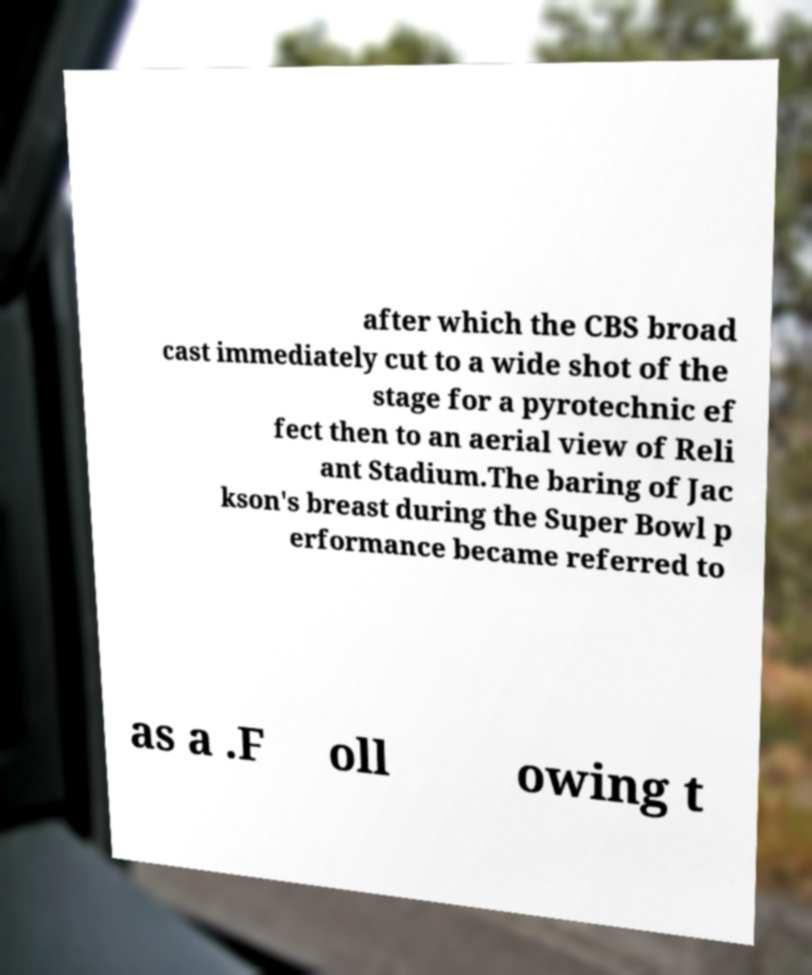I need the written content from this picture converted into text. Can you do that? after which the CBS broad cast immediately cut to a wide shot of the stage for a pyrotechnic ef fect then to an aerial view of Reli ant Stadium.The baring of Jac kson's breast during the Super Bowl p erformance became referred to as a .F oll owing t 